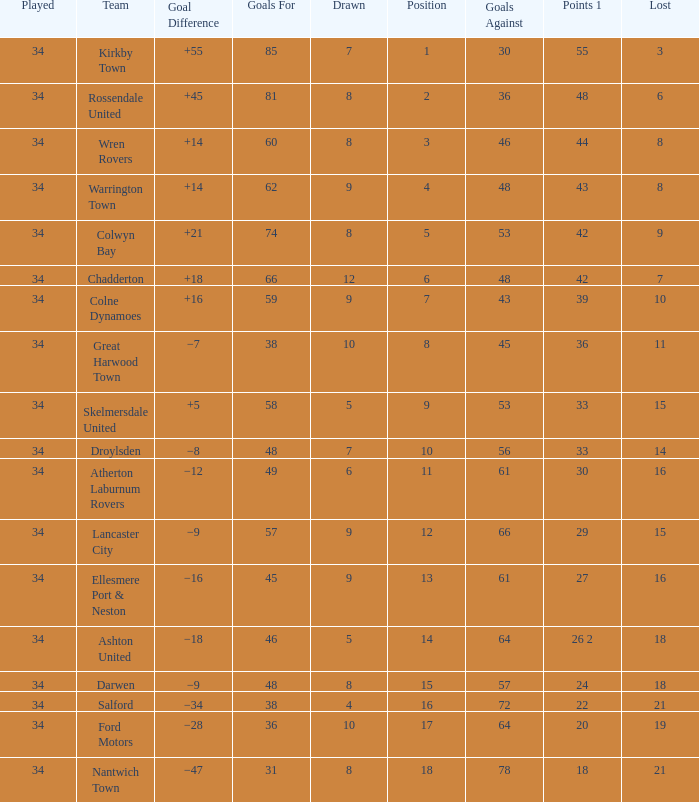What is the total number of positions when there are more than 48 goals against, 1 of 29 points are played, and less than 34 games have been played? 0.0. 